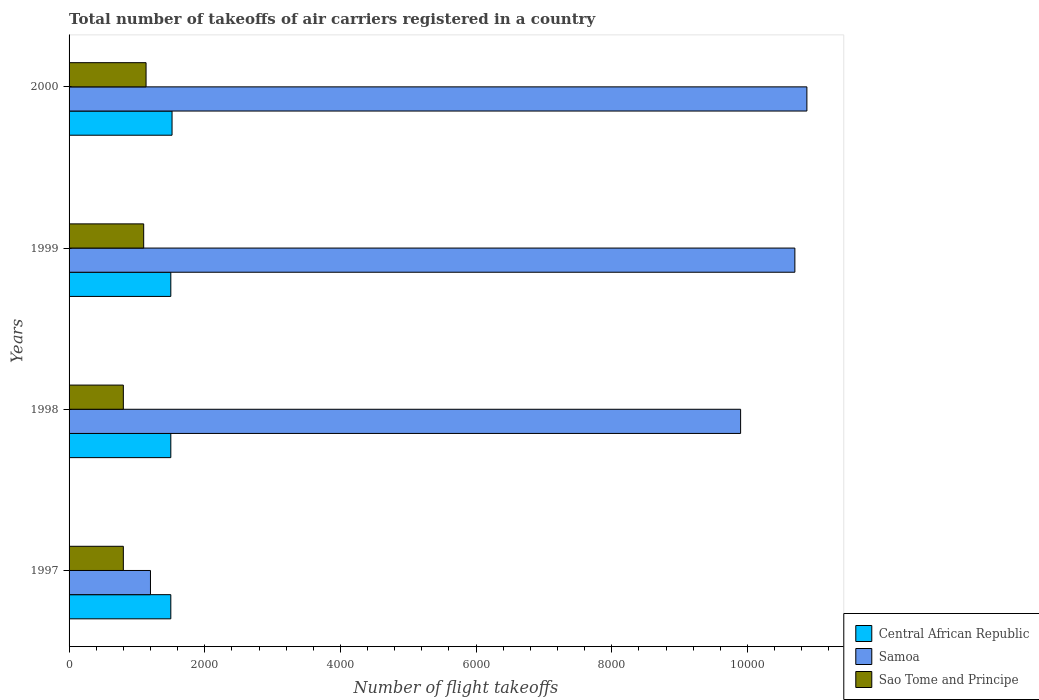How many groups of bars are there?
Your answer should be compact. 4. How many bars are there on the 2nd tick from the top?
Give a very brief answer. 3. In how many cases, is the number of bars for a given year not equal to the number of legend labels?
Keep it short and to the point. 0. What is the total number of flight takeoffs in Central African Republic in 1998?
Provide a short and direct response. 1500. Across all years, what is the maximum total number of flight takeoffs in Samoa?
Provide a succinct answer. 1.09e+04. Across all years, what is the minimum total number of flight takeoffs in Central African Republic?
Ensure brevity in your answer.  1500. In which year was the total number of flight takeoffs in Sao Tome and Principe maximum?
Offer a very short reply. 2000. What is the total total number of flight takeoffs in Samoa in the graph?
Provide a short and direct response. 3.27e+04. What is the difference between the total number of flight takeoffs in Samoa in 1997 and the total number of flight takeoffs in Sao Tome and Principe in 1999?
Make the answer very short. 100. What is the average total number of flight takeoffs in Samoa per year?
Your answer should be compact. 8169.25. In the year 1998, what is the difference between the total number of flight takeoffs in Samoa and total number of flight takeoffs in Sao Tome and Principe?
Give a very brief answer. 9100. What is the difference between the highest and the second highest total number of flight takeoffs in Central African Republic?
Your answer should be very brief. 18. What is the difference between the highest and the lowest total number of flight takeoffs in Samoa?
Offer a very short reply. 9677. In how many years, is the total number of flight takeoffs in Central African Republic greater than the average total number of flight takeoffs in Central African Republic taken over all years?
Make the answer very short. 1. What does the 2nd bar from the top in 1997 represents?
Offer a terse response. Samoa. What does the 2nd bar from the bottom in 1998 represents?
Ensure brevity in your answer.  Samoa. Is it the case that in every year, the sum of the total number of flight takeoffs in Samoa and total number of flight takeoffs in Central African Republic is greater than the total number of flight takeoffs in Sao Tome and Principe?
Your answer should be compact. Yes. Are the values on the major ticks of X-axis written in scientific E-notation?
Your answer should be compact. No. Does the graph contain any zero values?
Your response must be concise. No. Where does the legend appear in the graph?
Your answer should be compact. Bottom right. How many legend labels are there?
Provide a succinct answer. 3. What is the title of the graph?
Offer a terse response. Total number of takeoffs of air carriers registered in a country. What is the label or title of the X-axis?
Your answer should be compact. Number of flight takeoffs. What is the label or title of the Y-axis?
Your answer should be very brief. Years. What is the Number of flight takeoffs in Central African Republic in 1997?
Offer a very short reply. 1500. What is the Number of flight takeoffs of Samoa in 1997?
Your answer should be compact. 1200. What is the Number of flight takeoffs in Sao Tome and Principe in 1997?
Your answer should be very brief. 800. What is the Number of flight takeoffs in Central African Republic in 1998?
Your response must be concise. 1500. What is the Number of flight takeoffs of Samoa in 1998?
Offer a terse response. 9900. What is the Number of flight takeoffs in Sao Tome and Principe in 1998?
Your answer should be compact. 800. What is the Number of flight takeoffs of Central African Republic in 1999?
Give a very brief answer. 1500. What is the Number of flight takeoffs in Samoa in 1999?
Offer a terse response. 1.07e+04. What is the Number of flight takeoffs of Sao Tome and Principe in 1999?
Your answer should be compact. 1100. What is the Number of flight takeoffs of Central African Republic in 2000?
Give a very brief answer. 1518. What is the Number of flight takeoffs of Samoa in 2000?
Give a very brief answer. 1.09e+04. What is the Number of flight takeoffs of Sao Tome and Principe in 2000?
Your response must be concise. 1135. Across all years, what is the maximum Number of flight takeoffs of Central African Republic?
Make the answer very short. 1518. Across all years, what is the maximum Number of flight takeoffs in Samoa?
Your response must be concise. 1.09e+04. Across all years, what is the maximum Number of flight takeoffs in Sao Tome and Principe?
Make the answer very short. 1135. Across all years, what is the minimum Number of flight takeoffs in Central African Republic?
Give a very brief answer. 1500. Across all years, what is the minimum Number of flight takeoffs in Samoa?
Offer a very short reply. 1200. Across all years, what is the minimum Number of flight takeoffs in Sao Tome and Principe?
Your answer should be very brief. 800. What is the total Number of flight takeoffs in Central African Republic in the graph?
Your response must be concise. 6018. What is the total Number of flight takeoffs in Samoa in the graph?
Your answer should be compact. 3.27e+04. What is the total Number of flight takeoffs in Sao Tome and Principe in the graph?
Offer a very short reply. 3835. What is the difference between the Number of flight takeoffs in Samoa in 1997 and that in 1998?
Offer a very short reply. -8700. What is the difference between the Number of flight takeoffs in Sao Tome and Principe in 1997 and that in 1998?
Provide a short and direct response. 0. What is the difference between the Number of flight takeoffs of Samoa in 1997 and that in 1999?
Offer a terse response. -9500. What is the difference between the Number of flight takeoffs of Sao Tome and Principe in 1997 and that in 1999?
Offer a terse response. -300. What is the difference between the Number of flight takeoffs in Central African Republic in 1997 and that in 2000?
Your response must be concise. -18. What is the difference between the Number of flight takeoffs in Samoa in 1997 and that in 2000?
Make the answer very short. -9677. What is the difference between the Number of flight takeoffs in Sao Tome and Principe in 1997 and that in 2000?
Give a very brief answer. -335. What is the difference between the Number of flight takeoffs in Central African Republic in 1998 and that in 1999?
Offer a terse response. 0. What is the difference between the Number of flight takeoffs of Samoa in 1998 and that in 1999?
Your answer should be very brief. -800. What is the difference between the Number of flight takeoffs of Sao Tome and Principe in 1998 and that in 1999?
Your answer should be compact. -300. What is the difference between the Number of flight takeoffs of Samoa in 1998 and that in 2000?
Offer a terse response. -977. What is the difference between the Number of flight takeoffs in Sao Tome and Principe in 1998 and that in 2000?
Ensure brevity in your answer.  -335. What is the difference between the Number of flight takeoffs in Samoa in 1999 and that in 2000?
Your answer should be very brief. -177. What is the difference between the Number of flight takeoffs in Sao Tome and Principe in 1999 and that in 2000?
Provide a succinct answer. -35. What is the difference between the Number of flight takeoffs in Central African Republic in 1997 and the Number of flight takeoffs in Samoa in 1998?
Make the answer very short. -8400. What is the difference between the Number of flight takeoffs of Central African Republic in 1997 and the Number of flight takeoffs of Sao Tome and Principe in 1998?
Provide a succinct answer. 700. What is the difference between the Number of flight takeoffs of Samoa in 1997 and the Number of flight takeoffs of Sao Tome and Principe in 1998?
Keep it short and to the point. 400. What is the difference between the Number of flight takeoffs of Central African Republic in 1997 and the Number of flight takeoffs of Samoa in 1999?
Provide a succinct answer. -9200. What is the difference between the Number of flight takeoffs in Central African Republic in 1997 and the Number of flight takeoffs in Samoa in 2000?
Your answer should be very brief. -9377. What is the difference between the Number of flight takeoffs of Central African Republic in 1997 and the Number of flight takeoffs of Sao Tome and Principe in 2000?
Keep it short and to the point. 365. What is the difference between the Number of flight takeoffs of Samoa in 1997 and the Number of flight takeoffs of Sao Tome and Principe in 2000?
Provide a short and direct response. 65. What is the difference between the Number of flight takeoffs of Central African Republic in 1998 and the Number of flight takeoffs of Samoa in 1999?
Your answer should be compact. -9200. What is the difference between the Number of flight takeoffs of Central African Republic in 1998 and the Number of flight takeoffs of Sao Tome and Principe in 1999?
Keep it short and to the point. 400. What is the difference between the Number of flight takeoffs of Samoa in 1998 and the Number of flight takeoffs of Sao Tome and Principe in 1999?
Give a very brief answer. 8800. What is the difference between the Number of flight takeoffs in Central African Republic in 1998 and the Number of flight takeoffs in Samoa in 2000?
Offer a terse response. -9377. What is the difference between the Number of flight takeoffs in Central African Republic in 1998 and the Number of flight takeoffs in Sao Tome and Principe in 2000?
Your answer should be very brief. 365. What is the difference between the Number of flight takeoffs in Samoa in 1998 and the Number of flight takeoffs in Sao Tome and Principe in 2000?
Provide a succinct answer. 8765. What is the difference between the Number of flight takeoffs of Central African Republic in 1999 and the Number of flight takeoffs of Samoa in 2000?
Offer a terse response. -9377. What is the difference between the Number of flight takeoffs in Central African Republic in 1999 and the Number of flight takeoffs in Sao Tome and Principe in 2000?
Offer a very short reply. 365. What is the difference between the Number of flight takeoffs of Samoa in 1999 and the Number of flight takeoffs of Sao Tome and Principe in 2000?
Make the answer very short. 9565. What is the average Number of flight takeoffs of Central African Republic per year?
Give a very brief answer. 1504.5. What is the average Number of flight takeoffs in Samoa per year?
Provide a short and direct response. 8169.25. What is the average Number of flight takeoffs in Sao Tome and Principe per year?
Offer a very short reply. 958.75. In the year 1997, what is the difference between the Number of flight takeoffs in Central African Republic and Number of flight takeoffs in Samoa?
Make the answer very short. 300. In the year 1997, what is the difference between the Number of flight takeoffs of Central African Republic and Number of flight takeoffs of Sao Tome and Principe?
Offer a terse response. 700. In the year 1998, what is the difference between the Number of flight takeoffs of Central African Republic and Number of flight takeoffs of Samoa?
Your answer should be compact. -8400. In the year 1998, what is the difference between the Number of flight takeoffs in Central African Republic and Number of flight takeoffs in Sao Tome and Principe?
Ensure brevity in your answer.  700. In the year 1998, what is the difference between the Number of flight takeoffs in Samoa and Number of flight takeoffs in Sao Tome and Principe?
Offer a terse response. 9100. In the year 1999, what is the difference between the Number of flight takeoffs in Central African Republic and Number of flight takeoffs in Samoa?
Your response must be concise. -9200. In the year 1999, what is the difference between the Number of flight takeoffs of Samoa and Number of flight takeoffs of Sao Tome and Principe?
Provide a succinct answer. 9600. In the year 2000, what is the difference between the Number of flight takeoffs of Central African Republic and Number of flight takeoffs of Samoa?
Your response must be concise. -9359. In the year 2000, what is the difference between the Number of flight takeoffs of Central African Republic and Number of flight takeoffs of Sao Tome and Principe?
Keep it short and to the point. 383. In the year 2000, what is the difference between the Number of flight takeoffs in Samoa and Number of flight takeoffs in Sao Tome and Principe?
Your response must be concise. 9742. What is the ratio of the Number of flight takeoffs of Central African Republic in 1997 to that in 1998?
Provide a succinct answer. 1. What is the ratio of the Number of flight takeoffs of Samoa in 1997 to that in 1998?
Offer a terse response. 0.12. What is the ratio of the Number of flight takeoffs in Sao Tome and Principe in 1997 to that in 1998?
Provide a short and direct response. 1. What is the ratio of the Number of flight takeoffs in Central African Republic in 1997 to that in 1999?
Offer a very short reply. 1. What is the ratio of the Number of flight takeoffs in Samoa in 1997 to that in 1999?
Keep it short and to the point. 0.11. What is the ratio of the Number of flight takeoffs of Sao Tome and Principe in 1997 to that in 1999?
Ensure brevity in your answer.  0.73. What is the ratio of the Number of flight takeoffs in Central African Republic in 1997 to that in 2000?
Your response must be concise. 0.99. What is the ratio of the Number of flight takeoffs of Samoa in 1997 to that in 2000?
Make the answer very short. 0.11. What is the ratio of the Number of flight takeoffs of Sao Tome and Principe in 1997 to that in 2000?
Ensure brevity in your answer.  0.7. What is the ratio of the Number of flight takeoffs of Central African Republic in 1998 to that in 1999?
Keep it short and to the point. 1. What is the ratio of the Number of flight takeoffs in Samoa in 1998 to that in 1999?
Provide a short and direct response. 0.93. What is the ratio of the Number of flight takeoffs of Sao Tome and Principe in 1998 to that in 1999?
Your response must be concise. 0.73. What is the ratio of the Number of flight takeoffs in Samoa in 1998 to that in 2000?
Offer a very short reply. 0.91. What is the ratio of the Number of flight takeoffs of Sao Tome and Principe in 1998 to that in 2000?
Keep it short and to the point. 0.7. What is the ratio of the Number of flight takeoffs of Samoa in 1999 to that in 2000?
Provide a succinct answer. 0.98. What is the ratio of the Number of flight takeoffs in Sao Tome and Principe in 1999 to that in 2000?
Provide a short and direct response. 0.97. What is the difference between the highest and the second highest Number of flight takeoffs of Samoa?
Your answer should be very brief. 177. What is the difference between the highest and the second highest Number of flight takeoffs of Sao Tome and Principe?
Make the answer very short. 35. What is the difference between the highest and the lowest Number of flight takeoffs in Central African Republic?
Your answer should be compact. 18. What is the difference between the highest and the lowest Number of flight takeoffs in Samoa?
Keep it short and to the point. 9677. What is the difference between the highest and the lowest Number of flight takeoffs of Sao Tome and Principe?
Give a very brief answer. 335. 